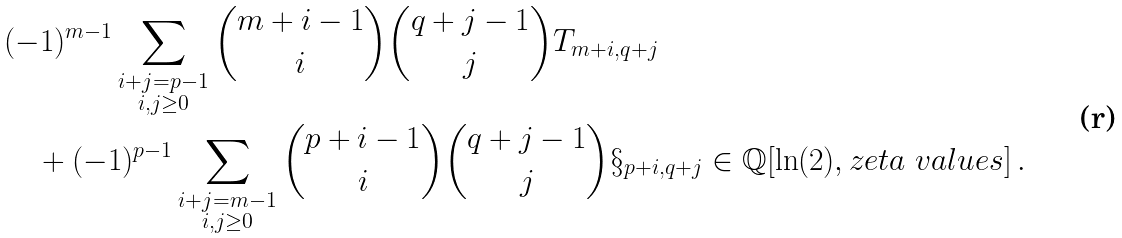Convert formula to latex. <formula><loc_0><loc_0><loc_500><loc_500>& ( - 1 ) ^ { m - 1 } \sum _ { \substack { i + j = p - 1 \\ i , j \geq 0 } } \binom { m + i - 1 } { i } \binom { q + j - 1 } { j } T _ { m + i , q + j } \\ & \quad + ( - 1 ) ^ { p - 1 } \sum _ { \substack { i + j = m - 1 \\ i , j \geq 0 } } \binom { p + i - 1 } { i } \binom { q + j - 1 } { j } \S _ { p + i , q + j } \in \mathbb { Q } [ \ln ( 2 ) , z e t a \ v a l u e s ] \, .</formula> 